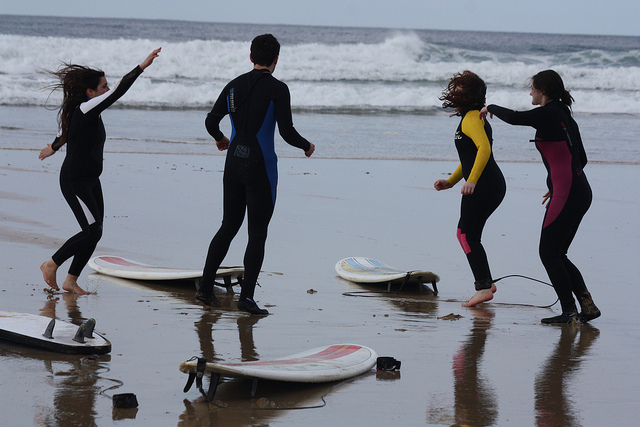Describe the attire of the people. The group is dressed in full-length wetsuits, which provide insulation and protection in the water. The wetsuits have different color patterns, with notable blue and yellow accents. 